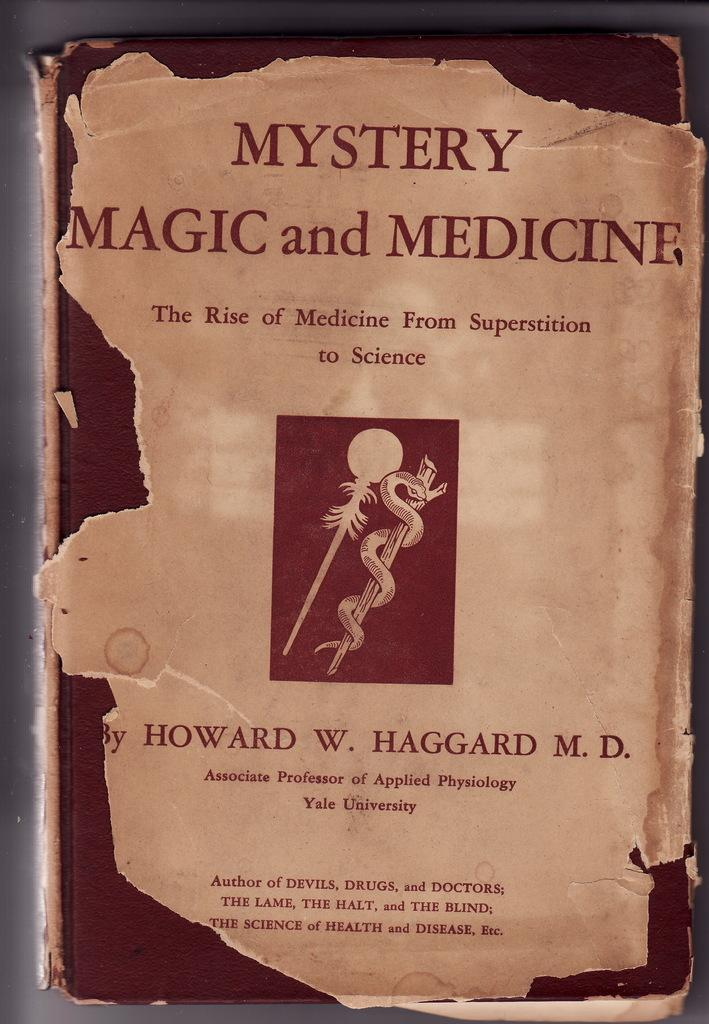<image>
Give a short and clear explanation of the subsequent image. A damaged copy of the book Mystery Magic and Medicine by Howard W Haggard. 